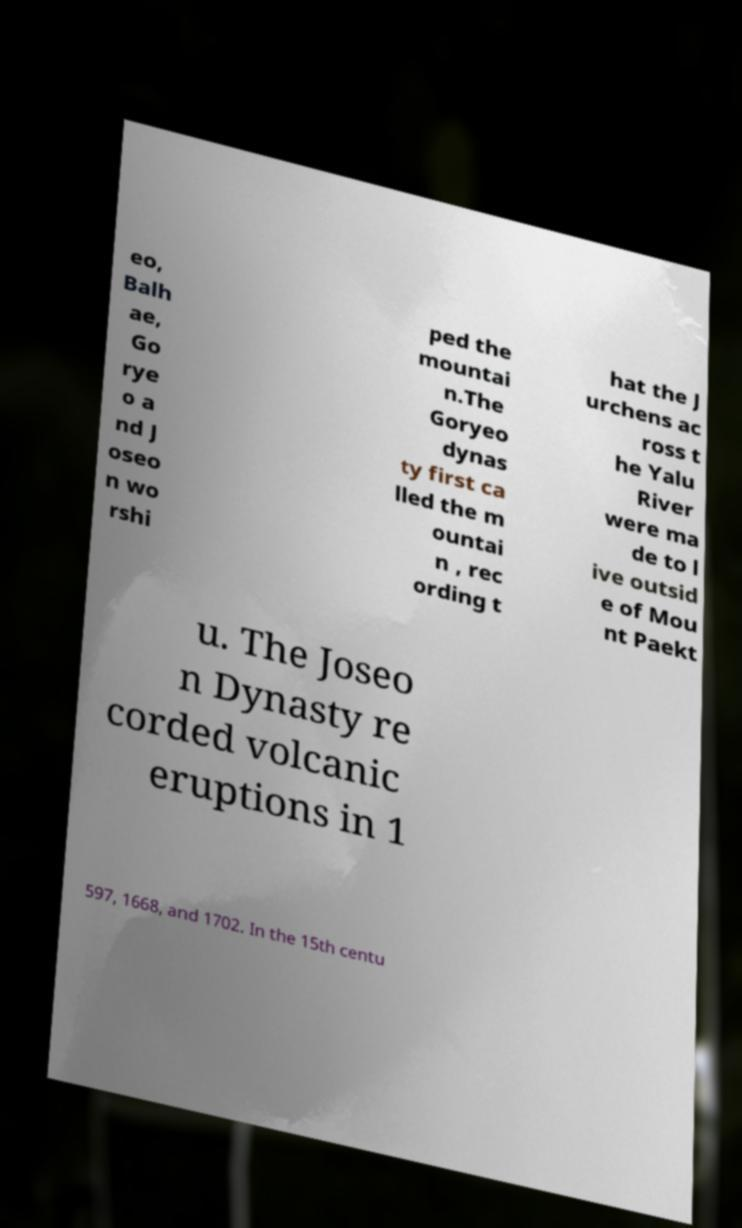For documentation purposes, I need the text within this image transcribed. Could you provide that? eo, Balh ae, Go rye o a nd J oseo n wo rshi ped the mountai n.The Goryeo dynas ty first ca lled the m ountai n , rec ording t hat the J urchens ac ross t he Yalu River were ma de to l ive outsid e of Mou nt Paekt u. The Joseo n Dynasty re corded volcanic eruptions in 1 597, 1668, and 1702. In the 15th centu 